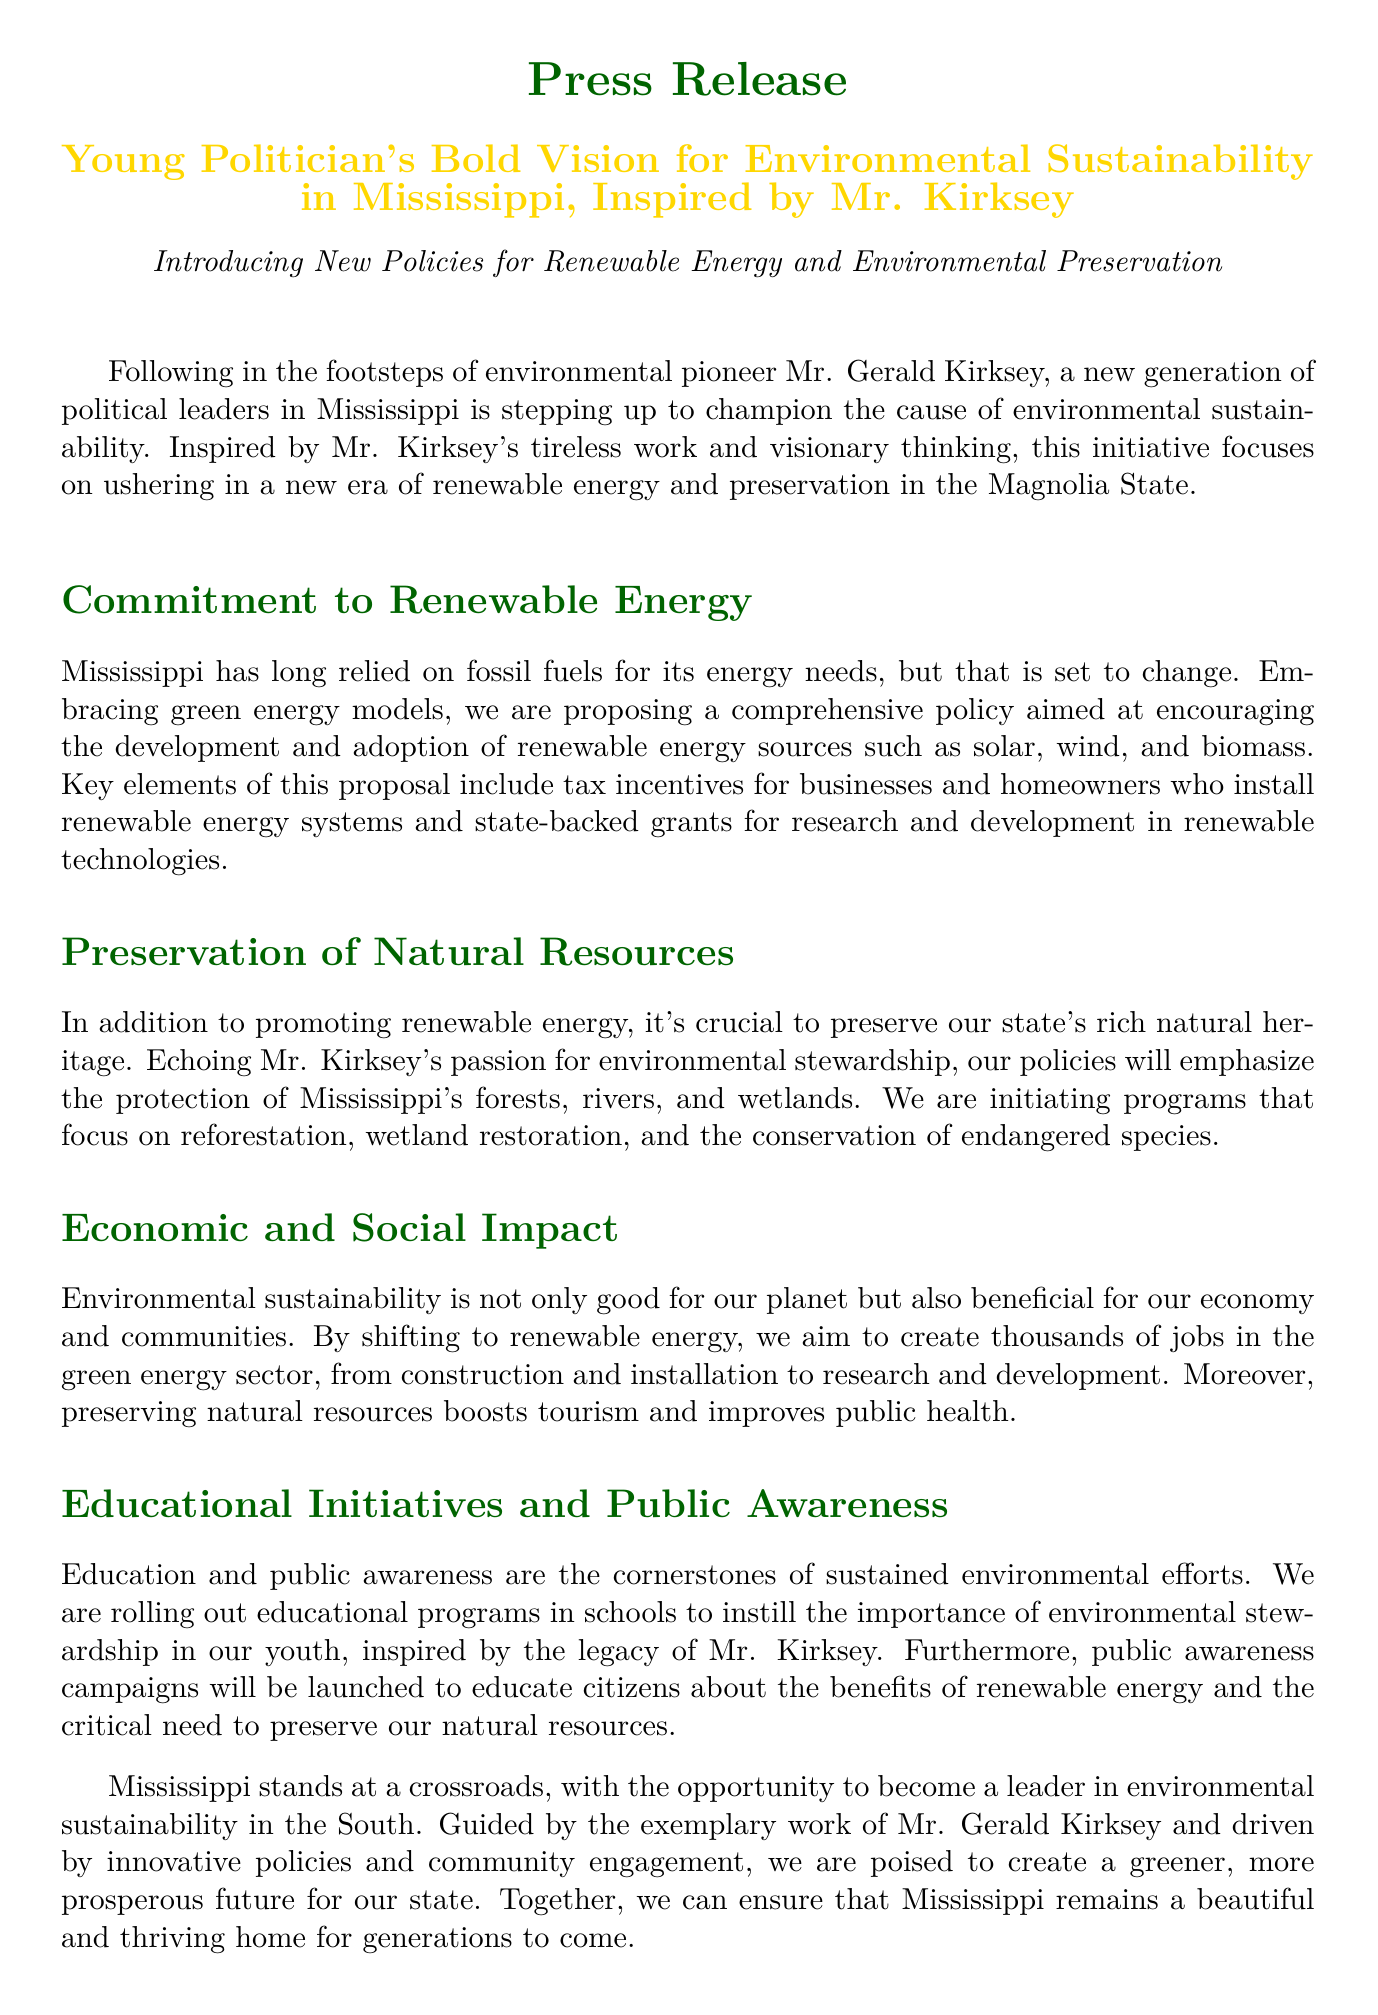What is the name of the environmental pioneer mentioned? The document refers to Mr. Gerald Kirksey as an environmental pioneer.
Answer: Mr. Gerald Kirksey What type of energy sources does the policy focus on? The document mentions renewable energy sources such as solar, wind, and biomass.
Answer: Renewable energy sources What are two key elements of the renewable energy proposal? The proposal includes tax incentives and state-backed grants for research and development.
Answer: Tax incentives and state-backed grants What is the primary goal of the educational initiatives mentioned? The educational programs aim to instill the importance of environmental stewardship in youth.
Answer: Environmental stewardship How many jobs does the shift to renewable energy aim to create? The document states that thousands of jobs will be created in the green energy sector.
Answer: Thousands of jobs 